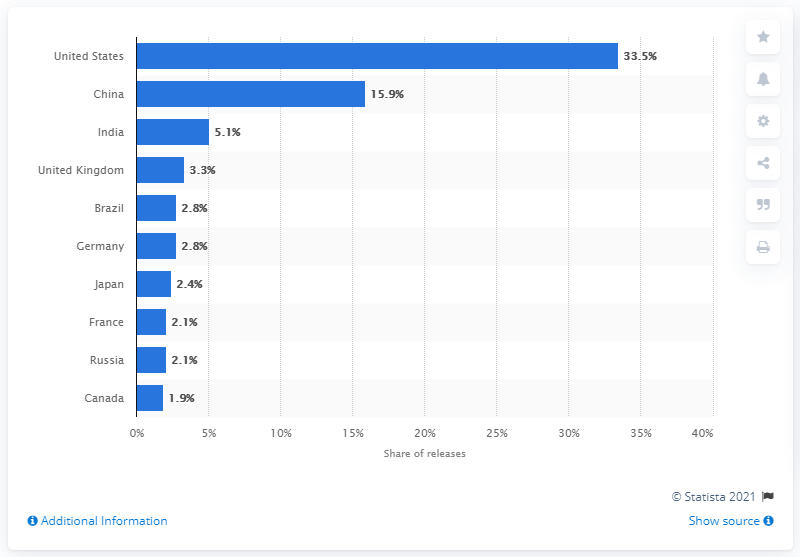Mention a couple of crucial points in this snapshot. In 2017, China came in second in terms of app releases. In the combined iOS and Android market, the United States accounted for approximately 33.5% of all app releases. 